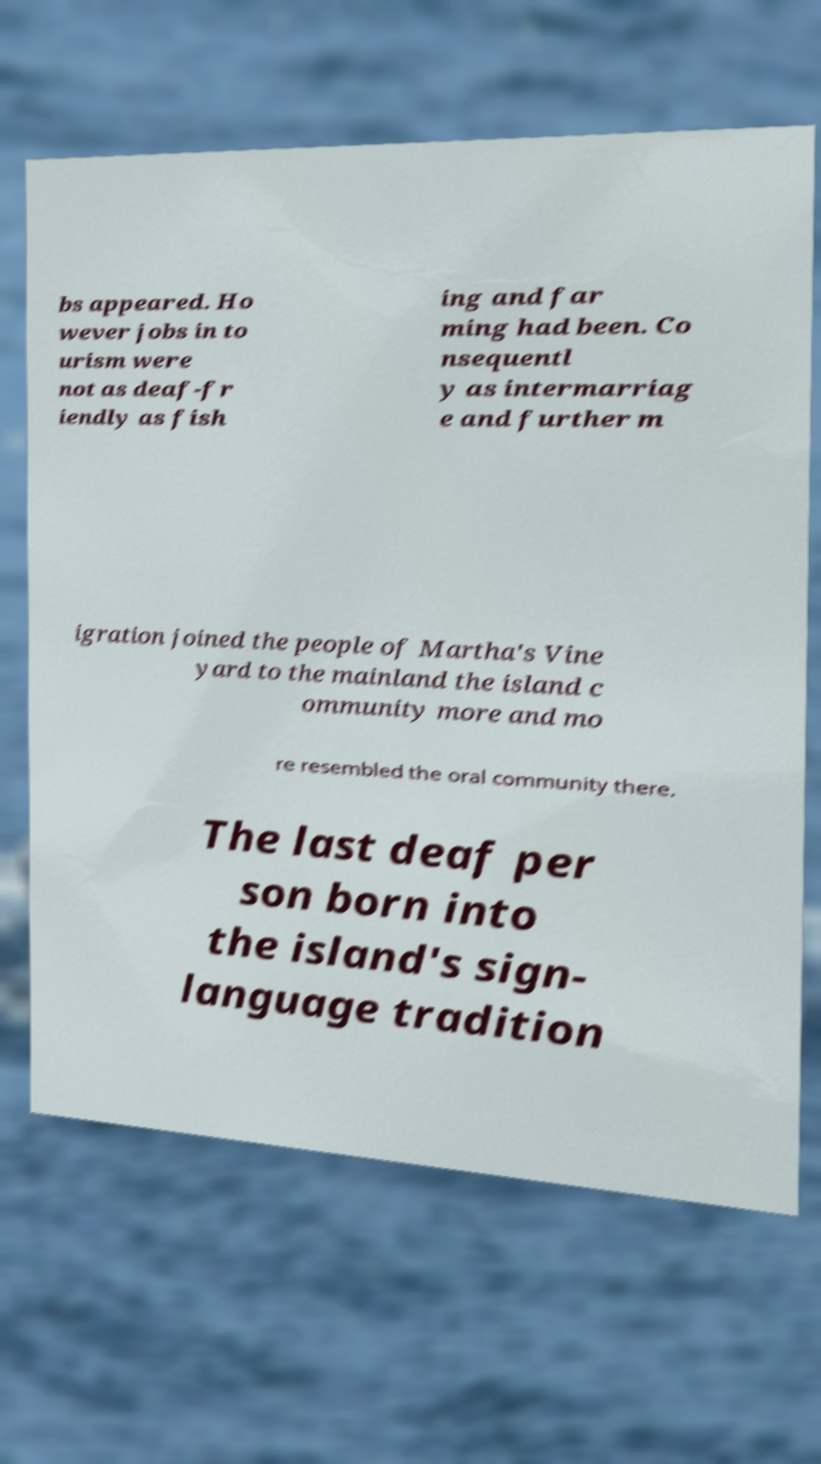Please read and relay the text visible in this image. What does it say? bs appeared. Ho wever jobs in to urism were not as deaf-fr iendly as fish ing and far ming had been. Co nsequentl y as intermarriag e and further m igration joined the people of Martha's Vine yard to the mainland the island c ommunity more and mo re resembled the oral community there. The last deaf per son born into the island's sign- language tradition 